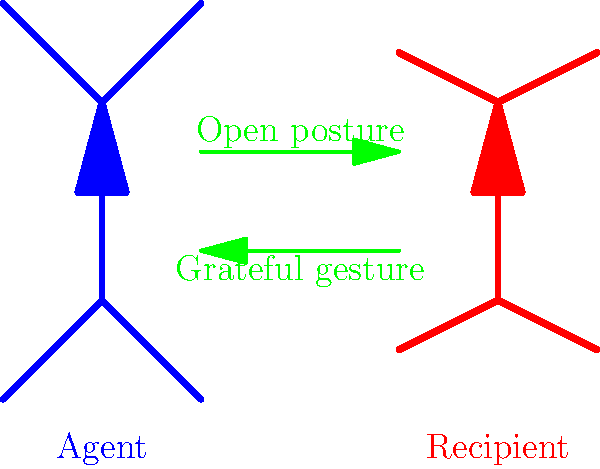Based on the diagram showing the body language of the agent and recipient during an act of kindness, what can be inferred about their interaction? To analyze the body language depicted in the diagram, let's break it down step-by-step:

1. Agent's posture:
   - The agent (blue figure) is standing upright with arms slightly raised.
   - This suggests an open and welcoming posture.

2. Recipient's posture:
   - The recipient (red figure) is also standing upright but with arms slightly lowered.
   - This indicates a receptive and possibly grateful stance.

3. Interaction indicators:
   - There are two green arrows between the figures.
   - The upper arrow points from the agent to the recipient, labeled "Open posture."
   - The lower arrow points from the recipient to the agent, labeled "Grateful gesture."

4. Interpretation:
   - The agent's open posture suggests they are offering help or kindness.
   - The recipient's stance and the "Grateful gesture" arrow imply they are accepting and appreciating the kindness.

5. Overall interaction:
   - The body language of both figures and the directional arrows indicate a positive, mutually engaging interaction.
   - The openness of the agent and the gratitude of the recipient suggest a successful act of kindness.
Answer: Positive, mutually engaging interaction with open kindness and grateful reception 